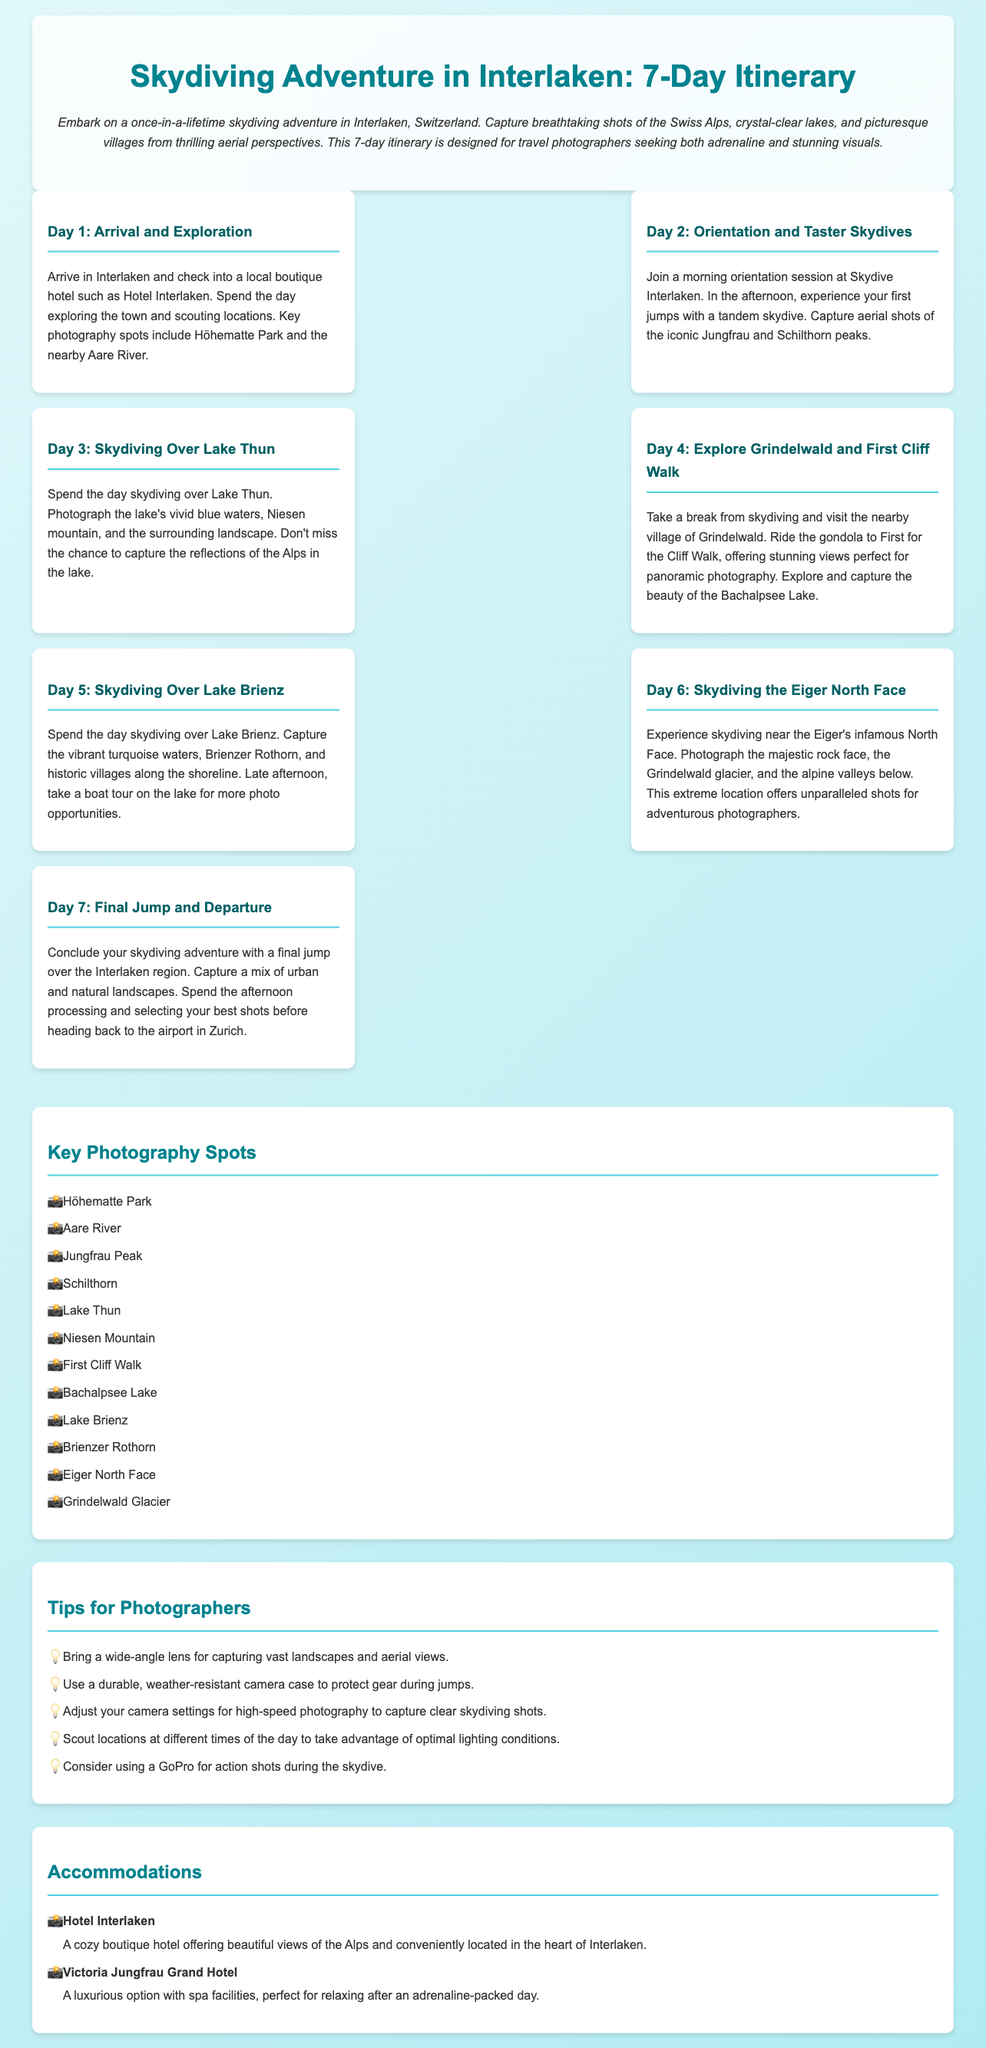What is the duration of the itinerary? The itinerary spans 7 days in Interlaken for a skydiving adventure.
Answer: 7 days What is a recommended hotel for accommodation? The document lists Hotel Interlaken as a cozy boutique hotel option.
Answer: Hotel Interlaken On which day is skydiving over Lake Thun scheduled? The day of skydiving over Lake Thun is specifically mentioned as the third day of the itinerary.
Answer: Day 3 What photography spot is recommended for aerial shots? The itinerary mentions capturing aerial shots of the iconic Jungfrau and Schilthorn peaks.
Answer: Jungfrau and Schilthorn What tip is given for capturing high-speed photography? The document suggests adjusting camera settings for high-speed photography to achieve clear skydiving shots.
Answer: Adjust camera settings How many photography spots are listed in the itinerary? The section titled "Key Photography Spots" provides a list of specific locations, totaling 12.
Answer: 12 What is the primary focus of the itinerary? The primary focus is on a skydiving adventure in Interlaken, specifically designed for travel photographers.
Answer: Skydiving adventure Which location is visited on Day 4? The itinerary notes that Day 4 involves visiting Grindelwald and the First Cliff Walk.
Answer: Grindelwald What activity is suggested for the final day? The final day of the itinerary suggests concluding with a last jump over the Interlaken region.
Answer: Final jump 